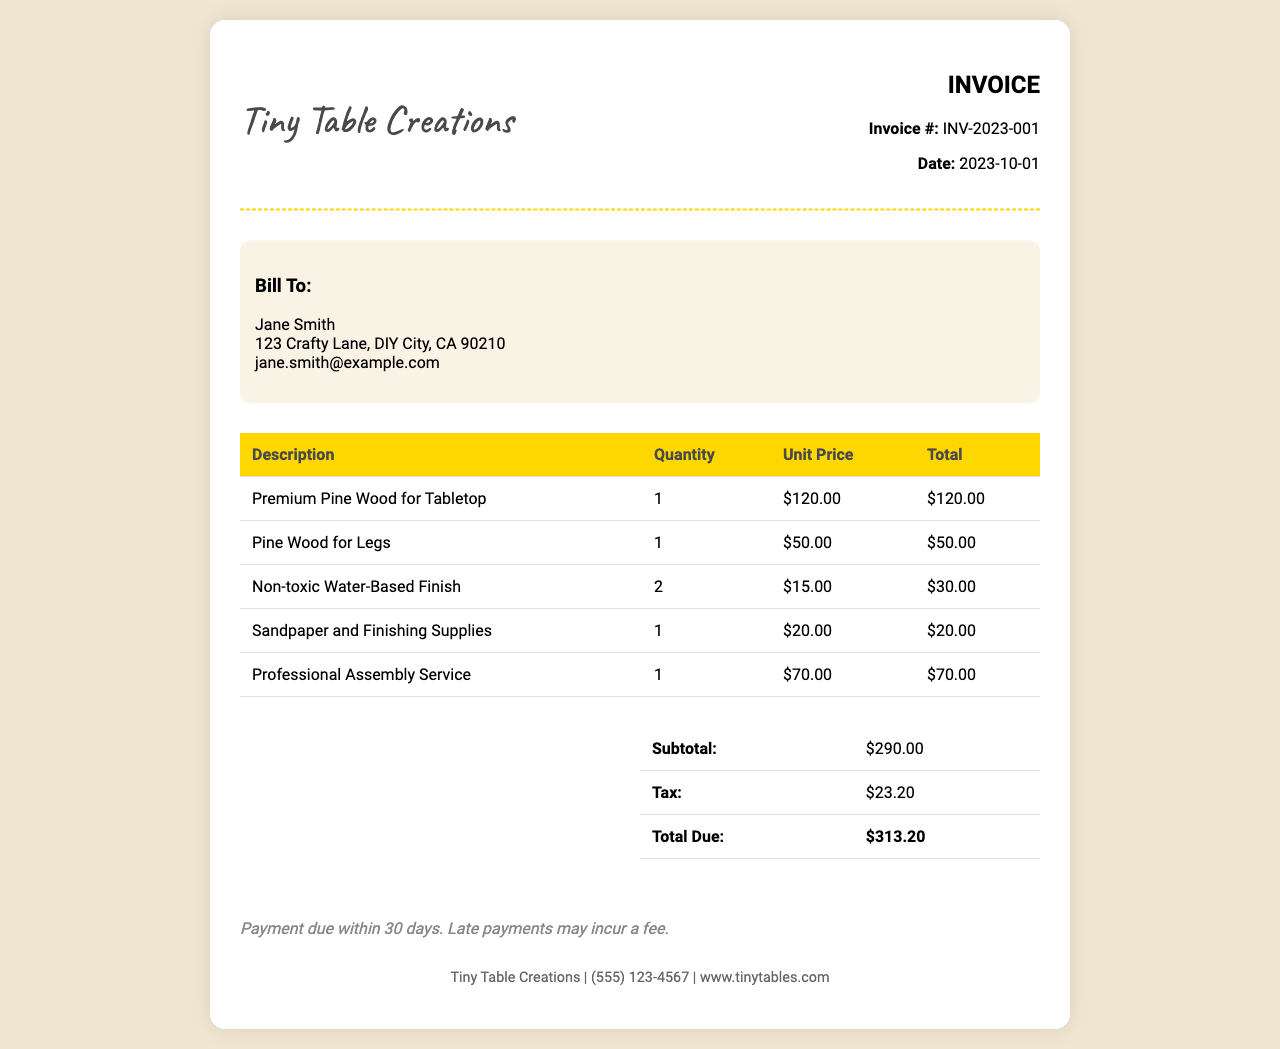What is the invoice number? The invoice number is stated at the top of the document under "Invoice #".
Answer: INV-2023-001 Who is the customer? The customer details are listed in the "Bill To" section.
Answer: Jane Smith What is the total due amount? The total due amount is calculated in the summary section of the document.
Answer: $313.20 How much did the professional assembly service cost? The cost for the professional assembly service is listed in the itemized table.
Answer: $70.00 What is the date of the invoice? The invoice date is displayed near the invoice number.
Answer: 2023-10-01 What type of finish is used? The type of finish is mentioned in the itemized list under a specific description.
Answer: Non-toxic Water-Based Finish How many different items are charged in the invoice? The number of different items is shown in the itemized table.
Answer: 5 What is the subtotal before tax? The subtotal is identified in the summary table of the document.
Answer: $290.00 What are the payment terms? The payment terms are provided at the bottom of the document.
Answer: Payment due within 30 days 